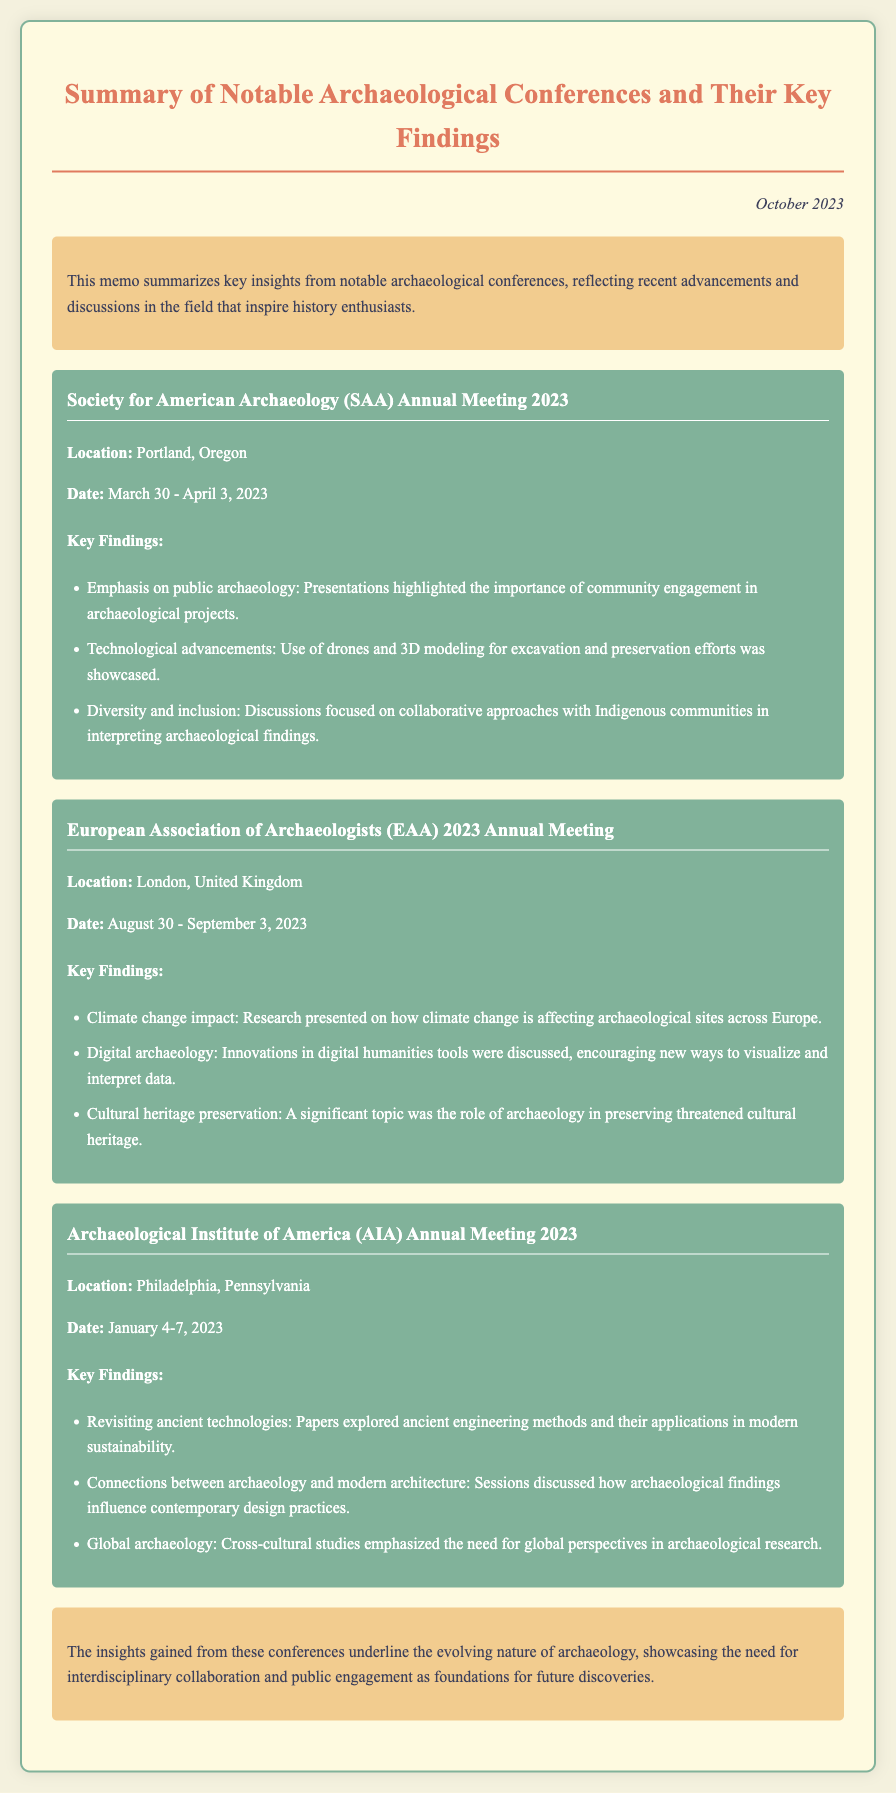what was the location of the SAA Annual Meeting 2023? The SAA Annual Meeting 2023 was held in Portland, Oregon.
Answer: Portland, Oregon when did the EAA 2023 Annual Meeting take place? The EAA 2023 Annual Meeting was held from August 30 to September 3, 2023.
Answer: August 30 - September 3, 2023 what is one key finding from the AIA Annual Meeting 2023? One key finding from the AIA Annual Meeting 2023 was about ancient engineering methods and their applications in modern sustainability.
Answer: Ancient engineering methods how did community engagement feature in the SAA Annual Meeting? Presentations highlighted the importance of community engagement in archaeological projects.
Answer: Community engagement which conference discussed the role of archaeology in preserving cultural heritage? The European Association of Archaeologists (EAA) 2023 Annual Meeting discussed cultural heritage preservation.
Answer: EAA 2023 Annual Meeting what is a common theme observed in the conferences summarized? A common theme is the emphasis on interdisciplinary collaboration and public engagement.
Answer: Interdisciplinary collaboration and public engagement 